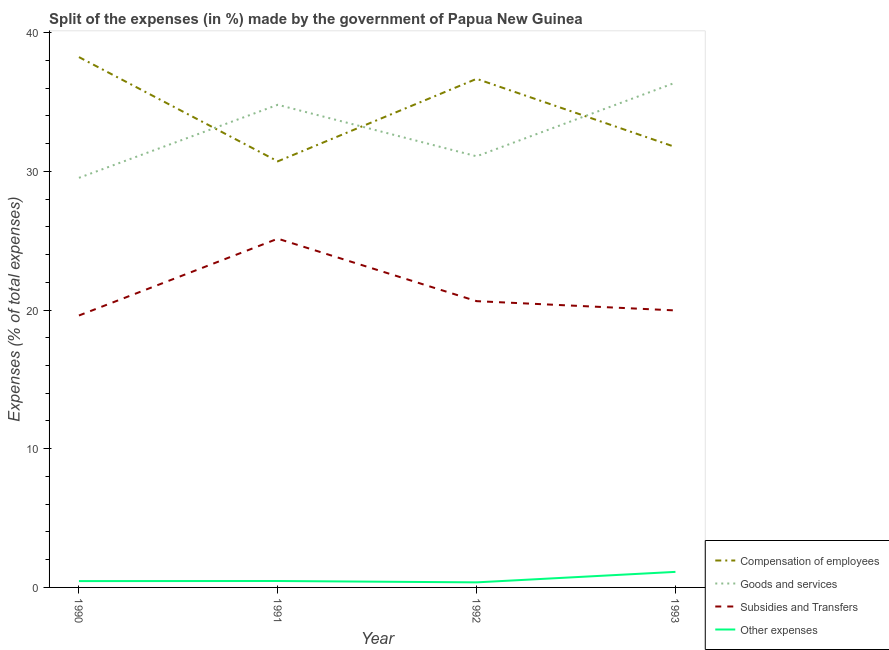How many different coloured lines are there?
Offer a terse response. 4. Is the number of lines equal to the number of legend labels?
Offer a very short reply. Yes. What is the percentage of amount spent on other expenses in 1990?
Ensure brevity in your answer.  0.46. Across all years, what is the maximum percentage of amount spent on goods and services?
Provide a succinct answer. 36.4. Across all years, what is the minimum percentage of amount spent on goods and services?
Offer a very short reply. 29.53. In which year was the percentage of amount spent on subsidies maximum?
Your answer should be compact. 1991. What is the total percentage of amount spent on subsidies in the graph?
Provide a succinct answer. 85.36. What is the difference between the percentage of amount spent on goods and services in 1991 and that in 1993?
Give a very brief answer. -1.6. What is the difference between the percentage of amount spent on subsidies in 1993 and the percentage of amount spent on goods and services in 1992?
Make the answer very short. -11.11. What is the average percentage of amount spent on goods and services per year?
Provide a short and direct response. 32.95. In the year 1992, what is the difference between the percentage of amount spent on compensation of employees and percentage of amount spent on subsidies?
Make the answer very short. 16.03. What is the ratio of the percentage of amount spent on compensation of employees in 1991 to that in 1993?
Provide a succinct answer. 0.97. Is the percentage of amount spent on subsidies in 1990 less than that in 1991?
Keep it short and to the point. Yes. What is the difference between the highest and the second highest percentage of amount spent on subsidies?
Your response must be concise. 4.51. What is the difference between the highest and the lowest percentage of amount spent on goods and services?
Provide a short and direct response. 6.87. Is it the case that in every year, the sum of the percentage of amount spent on compensation of employees and percentage of amount spent on goods and services is greater than the percentage of amount spent on subsidies?
Offer a very short reply. Yes. Does the percentage of amount spent on goods and services monotonically increase over the years?
Give a very brief answer. No. Is the percentage of amount spent on compensation of employees strictly less than the percentage of amount spent on subsidies over the years?
Ensure brevity in your answer.  No. What is the difference between two consecutive major ticks on the Y-axis?
Give a very brief answer. 10. How many legend labels are there?
Provide a succinct answer. 4. How are the legend labels stacked?
Provide a short and direct response. Vertical. What is the title of the graph?
Your answer should be very brief. Split of the expenses (in %) made by the government of Papua New Guinea. Does "Budget management" appear as one of the legend labels in the graph?
Ensure brevity in your answer.  No. What is the label or title of the Y-axis?
Offer a very short reply. Expenses (% of total expenses). What is the Expenses (% of total expenses) of Compensation of employees in 1990?
Provide a short and direct response. 38.24. What is the Expenses (% of total expenses) in Goods and services in 1990?
Your response must be concise. 29.53. What is the Expenses (% of total expenses) in Subsidies and Transfers in 1990?
Give a very brief answer. 19.61. What is the Expenses (% of total expenses) of Other expenses in 1990?
Give a very brief answer. 0.46. What is the Expenses (% of total expenses) in Compensation of employees in 1991?
Your answer should be compact. 30.72. What is the Expenses (% of total expenses) in Goods and services in 1991?
Offer a very short reply. 34.8. What is the Expenses (% of total expenses) of Subsidies and Transfers in 1991?
Offer a terse response. 25.15. What is the Expenses (% of total expenses) of Other expenses in 1991?
Your response must be concise. 0.46. What is the Expenses (% of total expenses) of Compensation of employees in 1992?
Ensure brevity in your answer.  36.67. What is the Expenses (% of total expenses) of Goods and services in 1992?
Your answer should be very brief. 31.08. What is the Expenses (% of total expenses) of Subsidies and Transfers in 1992?
Your response must be concise. 20.64. What is the Expenses (% of total expenses) of Other expenses in 1992?
Offer a terse response. 0.37. What is the Expenses (% of total expenses) of Compensation of employees in 1993?
Offer a terse response. 31.75. What is the Expenses (% of total expenses) in Goods and services in 1993?
Offer a terse response. 36.4. What is the Expenses (% of total expenses) in Subsidies and Transfers in 1993?
Provide a short and direct response. 19.97. What is the Expenses (% of total expenses) of Other expenses in 1993?
Your response must be concise. 1.12. Across all years, what is the maximum Expenses (% of total expenses) of Compensation of employees?
Your response must be concise. 38.24. Across all years, what is the maximum Expenses (% of total expenses) of Goods and services?
Your answer should be compact. 36.4. Across all years, what is the maximum Expenses (% of total expenses) of Subsidies and Transfers?
Give a very brief answer. 25.15. Across all years, what is the maximum Expenses (% of total expenses) in Other expenses?
Your answer should be compact. 1.12. Across all years, what is the minimum Expenses (% of total expenses) in Compensation of employees?
Provide a succinct answer. 30.72. Across all years, what is the minimum Expenses (% of total expenses) of Goods and services?
Offer a terse response. 29.53. Across all years, what is the minimum Expenses (% of total expenses) of Subsidies and Transfers?
Offer a very short reply. 19.61. Across all years, what is the minimum Expenses (% of total expenses) of Other expenses?
Offer a very short reply. 0.37. What is the total Expenses (% of total expenses) of Compensation of employees in the graph?
Your answer should be compact. 137.38. What is the total Expenses (% of total expenses) in Goods and services in the graph?
Make the answer very short. 131.81. What is the total Expenses (% of total expenses) of Subsidies and Transfers in the graph?
Your answer should be compact. 85.36. What is the total Expenses (% of total expenses) of Other expenses in the graph?
Provide a succinct answer. 2.41. What is the difference between the Expenses (% of total expenses) of Compensation of employees in 1990 and that in 1991?
Offer a terse response. 7.52. What is the difference between the Expenses (% of total expenses) in Goods and services in 1990 and that in 1991?
Keep it short and to the point. -5.27. What is the difference between the Expenses (% of total expenses) in Subsidies and Transfers in 1990 and that in 1991?
Give a very brief answer. -5.54. What is the difference between the Expenses (% of total expenses) in Other expenses in 1990 and that in 1991?
Make the answer very short. -0.01. What is the difference between the Expenses (% of total expenses) of Compensation of employees in 1990 and that in 1992?
Your answer should be compact. 1.57. What is the difference between the Expenses (% of total expenses) of Goods and services in 1990 and that in 1992?
Your answer should be compact. -1.55. What is the difference between the Expenses (% of total expenses) in Subsidies and Transfers in 1990 and that in 1992?
Offer a terse response. -1.03. What is the difference between the Expenses (% of total expenses) in Other expenses in 1990 and that in 1992?
Ensure brevity in your answer.  0.09. What is the difference between the Expenses (% of total expenses) in Compensation of employees in 1990 and that in 1993?
Provide a succinct answer. 6.49. What is the difference between the Expenses (% of total expenses) in Goods and services in 1990 and that in 1993?
Your answer should be compact. -6.87. What is the difference between the Expenses (% of total expenses) of Subsidies and Transfers in 1990 and that in 1993?
Ensure brevity in your answer.  -0.37. What is the difference between the Expenses (% of total expenses) in Other expenses in 1990 and that in 1993?
Your response must be concise. -0.67. What is the difference between the Expenses (% of total expenses) in Compensation of employees in 1991 and that in 1992?
Offer a very short reply. -5.95. What is the difference between the Expenses (% of total expenses) of Goods and services in 1991 and that in 1992?
Provide a short and direct response. 3.71. What is the difference between the Expenses (% of total expenses) in Subsidies and Transfers in 1991 and that in 1992?
Your answer should be compact. 4.51. What is the difference between the Expenses (% of total expenses) of Other expenses in 1991 and that in 1992?
Your answer should be very brief. 0.1. What is the difference between the Expenses (% of total expenses) in Compensation of employees in 1991 and that in 1993?
Provide a short and direct response. -1.03. What is the difference between the Expenses (% of total expenses) in Goods and services in 1991 and that in 1993?
Your answer should be very brief. -1.6. What is the difference between the Expenses (% of total expenses) in Subsidies and Transfers in 1991 and that in 1993?
Provide a short and direct response. 5.17. What is the difference between the Expenses (% of total expenses) of Other expenses in 1991 and that in 1993?
Offer a terse response. -0.66. What is the difference between the Expenses (% of total expenses) of Compensation of employees in 1992 and that in 1993?
Provide a short and direct response. 4.92. What is the difference between the Expenses (% of total expenses) of Goods and services in 1992 and that in 1993?
Your answer should be compact. -5.31. What is the difference between the Expenses (% of total expenses) of Subsidies and Transfers in 1992 and that in 1993?
Your response must be concise. 0.67. What is the difference between the Expenses (% of total expenses) of Other expenses in 1992 and that in 1993?
Your response must be concise. -0.76. What is the difference between the Expenses (% of total expenses) in Compensation of employees in 1990 and the Expenses (% of total expenses) in Goods and services in 1991?
Your answer should be compact. 3.44. What is the difference between the Expenses (% of total expenses) of Compensation of employees in 1990 and the Expenses (% of total expenses) of Subsidies and Transfers in 1991?
Keep it short and to the point. 13.09. What is the difference between the Expenses (% of total expenses) of Compensation of employees in 1990 and the Expenses (% of total expenses) of Other expenses in 1991?
Your answer should be compact. 37.77. What is the difference between the Expenses (% of total expenses) in Goods and services in 1990 and the Expenses (% of total expenses) in Subsidies and Transfers in 1991?
Ensure brevity in your answer.  4.39. What is the difference between the Expenses (% of total expenses) in Goods and services in 1990 and the Expenses (% of total expenses) in Other expenses in 1991?
Give a very brief answer. 29.07. What is the difference between the Expenses (% of total expenses) in Subsidies and Transfers in 1990 and the Expenses (% of total expenses) in Other expenses in 1991?
Provide a succinct answer. 19.14. What is the difference between the Expenses (% of total expenses) in Compensation of employees in 1990 and the Expenses (% of total expenses) in Goods and services in 1992?
Your answer should be very brief. 7.15. What is the difference between the Expenses (% of total expenses) in Compensation of employees in 1990 and the Expenses (% of total expenses) in Subsidies and Transfers in 1992?
Offer a terse response. 17.6. What is the difference between the Expenses (% of total expenses) of Compensation of employees in 1990 and the Expenses (% of total expenses) of Other expenses in 1992?
Your answer should be very brief. 37.87. What is the difference between the Expenses (% of total expenses) of Goods and services in 1990 and the Expenses (% of total expenses) of Subsidies and Transfers in 1992?
Keep it short and to the point. 8.89. What is the difference between the Expenses (% of total expenses) in Goods and services in 1990 and the Expenses (% of total expenses) in Other expenses in 1992?
Your response must be concise. 29.17. What is the difference between the Expenses (% of total expenses) of Subsidies and Transfers in 1990 and the Expenses (% of total expenses) of Other expenses in 1992?
Your answer should be compact. 19.24. What is the difference between the Expenses (% of total expenses) of Compensation of employees in 1990 and the Expenses (% of total expenses) of Goods and services in 1993?
Make the answer very short. 1.84. What is the difference between the Expenses (% of total expenses) in Compensation of employees in 1990 and the Expenses (% of total expenses) in Subsidies and Transfers in 1993?
Give a very brief answer. 18.27. What is the difference between the Expenses (% of total expenses) in Compensation of employees in 1990 and the Expenses (% of total expenses) in Other expenses in 1993?
Make the answer very short. 37.12. What is the difference between the Expenses (% of total expenses) in Goods and services in 1990 and the Expenses (% of total expenses) in Subsidies and Transfers in 1993?
Keep it short and to the point. 9.56. What is the difference between the Expenses (% of total expenses) of Goods and services in 1990 and the Expenses (% of total expenses) of Other expenses in 1993?
Provide a succinct answer. 28.41. What is the difference between the Expenses (% of total expenses) in Subsidies and Transfers in 1990 and the Expenses (% of total expenses) in Other expenses in 1993?
Offer a very short reply. 18.48. What is the difference between the Expenses (% of total expenses) in Compensation of employees in 1991 and the Expenses (% of total expenses) in Goods and services in 1992?
Offer a very short reply. -0.36. What is the difference between the Expenses (% of total expenses) in Compensation of employees in 1991 and the Expenses (% of total expenses) in Subsidies and Transfers in 1992?
Provide a succinct answer. 10.08. What is the difference between the Expenses (% of total expenses) of Compensation of employees in 1991 and the Expenses (% of total expenses) of Other expenses in 1992?
Keep it short and to the point. 30.36. What is the difference between the Expenses (% of total expenses) in Goods and services in 1991 and the Expenses (% of total expenses) in Subsidies and Transfers in 1992?
Provide a short and direct response. 14.16. What is the difference between the Expenses (% of total expenses) in Goods and services in 1991 and the Expenses (% of total expenses) in Other expenses in 1992?
Ensure brevity in your answer.  34.43. What is the difference between the Expenses (% of total expenses) of Subsidies and Transfers in 1991 and the Expenses (% of total expenses) of Other expenses in 1992?
Provide a succinct answer. 24.78. What is the difference between the Expenses (% of total expenses) of Compensation of employees in 1991 and the Expenses (% of total expenses) of Goods and services in 1993?
Your answer should be very brief. -5.68. What is the difference between the Expenses (% of total expenses) in Compensation of employees in 1991 and the Expenses (% of total expenses) in Subsidies and Transfers in 1993?
Your answer should be very brief. 10.75. What is the difference between the Expenses (% of total expenses) of Compensation of employees in 1991 and the Expenses (% of total expenses) of Other expenses in 1993?
Make the answer very short. 29.6. What is the difference between the Expenses (% of total expenses) of Goods and services in 1991 and the Expenses (% of total expenses) of Subsidies and Transfers in 1993?
Offer a terse response. 14.83. What is the difference between the Expenses (% of total expenses) of Goods and services in 1991 and the Expenses (% of total expenses) of Other expenses in 1993?
Your answer should be very brief. 33.68. What is the difference between the Expenses (% of total expenses) in Subsidies and Transfers in 1991 and the Expenses (% of total expenses) in Other expenses in 1993?
Your answer should be compact. 24.02. What is the difference between the Expenses (% of total expenses) in Compensation of employees in 1992 and the Expenses (% of total expenses) in Goods and services in 1993?
Give a very brief answer. 0.27. What is the difference between the Expenses (% of total expenses) in Compensation of employees in 1992 and the Expenses (% of total expenses) in Subsidies and Transfers in 1993?
Offer a very short reply. 16.7. What is the difference between the Expenses (% of total expenses) in Compensation of employees in 1992 and the Expenses (% of total expenses) in Other expenses in 1993?
Provide a succinct answer. 35.55. What is the difference between the Expenses (% of total expenses) of Goods and services in 1992 and the Expenses (% of total expenses) of Subsidies and Transfers in 1993?
Offer a terse response. 11.11. What is the difference between the Expenses (% of total expenses) in Goods and services in 1992 and the Expenses (% of total expenses) in Other expenses in 1993?
Your answer should be compact. 29.96. What is the difference between the Expenses (% of total expenses) in Subsidies and Transfers in 1992 and the Expenses (% of total expenses) in Other expenses in 1993?
Provide a succinct answer. 19.52. What is the average Expenses (% of total expenses) of Compensation of employees per year?
Your answer should be very brief. 34.34. What is the average Expenses (% of total expenses) in Goods and services per year?
Your answer should be very brief. 32.95. What is the average Expenses (% of total expenses) in Subsidies and Transfers per year?
Your answer should be compact. 21.34. What is the average Expenses (% of total expenses) in Other expenses per year?
Your answer should be very brief. 0.6. In the year 1990, what is the difference between the Expenses (% of total expenses) of Compensation of employees and Expenses (% of total expenses) of Goods and services?
Make the answer very short. 8.71. In the year 1990, what is the difference between the Expenses (% of total expenses) of Compensation of employees and Expenses (% of total expenses) of Subsidies and Transfers?
Offer a terse response. 18.63. In the year 1990, what is the difference between the Expenses (% of total expenses) of Compensation of employees and Expenses (% of total expenses) of Other expenses?
Ensure brevity in your answer.  37.78. In the year 1990, what is the difference between the Expenses (% of total expenses) of Goods and services and Expenses (% of total expenses) of Subsidies and Transfers?
Offer a very short reply. 9.93. In the year 1990, what is the difference between the Expenses (% of total expenses) in Goods and services and Expenses (% of total expenses) in Other expenses?
Provide a succinct answer. 29.08. In the year 1990, what is the difference between the Expenses (% of total expenses) of Subsidies and Transfers and Expenses (% of total expenses) of Other expenses?
Offer a very short reply. 19.15. In the year 1991, what is the difference between the Expenses (% of total expenses) of Compensation of employees and Expenses (% of total expenses) of Goods and services?
Ensure brevity in your answer.  -4.08. In the year 1991, what is the difference between the Expenses (% of total expenses) in Compensation of employees and Expenses (% of total expenses) in Subsidies and Transfers?
Provide a succinct answer. 5.58. In the year 1991, what is the difference between the Expenses (% of total expenses) of Compensation of employees and Expenses (% of total expenses) of Other expenses?
Give a very brief answer. 30.26. In the year 1991, what is the difference between the Expenses (% of total expenses) of Goods and services and Expenses (% of total expenses) of Subsidies and Transfers?
Make the answer very short. 9.65. In the year 1991, what is the difference between the Expenses (% of total expenses) of Goods and services and Expenses (% of total expenses) of Other expenses?
Your response must be concise. 34.34. In the year 1991, what is the difference between the Expenses (% of total expenses) of Subsidies and Transfers and Expenses (% of total expenses) of Other expenses?
Provide a succinct answer. 24.68. In the year 1992, what is the difference between the Expenses (% of total expenses) in Compensation of employees and Expenses (% of total expenses) in Goods and services?
Offer a terse response. 5.59. In the year 1992, what is the difference between the Expenses (% of total expenses) of Compensation of employees and Expenses (% of total expenses) of Subsidies and Transfers?
Your answer should be compact. 16.03. In the year 1992, what is the difference between the Expenses (% of total expenses) of Compensation of employees and Expenses (% of total expenses) of Other expenses?
Ensure brevity in your answer.  36.31. In the year 1992, what is the difference between the Expenses (% of total expenses) of Goods and services and Expenses (% of total expenses) of Subsidies and Transfers?
Offer a terse response. 10.44. In the year 1992, what is the difference between the Expenses (% of total expenses) in Goods and services and Expenses (% of total expenses) in Other expenses?
Keep it short and to the point. 30.72. In the year 1992, what is the difference between the Expenses (% of total expenses) of Subsidies and Transfers and Expenses (% of total expenses) of Other expenses?
Provide a short and direct response. 20.28. In the year 1993, what is the difference between the Expenses (% of total expenses) of Compensation of employees and Expenses (% of total expenses) of Goods and services?
Ensure brevity in your answer.  -4.65. In the year 1993, what is the difference between the Expenses (% of total expenses) in Compensation of employees and Expenses (% of total expenses) in Subsidies and Transfers?
Provide a short and direct response. 11.78. In the year 1993, what is the difference between the Expenses (% of total expenses) of Compensation of employees and Expenses (% of total expenses) of Other expenses?
Keep it short and to the point. 30.63. In the year 1993, what is the difference between the Expenses (% of total expenses) of Goods and services and Expenses (% of total expenses) of Subsidies and Transfers?
Your answer should be very brief. 16.43. In the year 1993, what is the difference between the Expenses (% of total expenses) in Goods and services and Expenses (% of total expenses) in Other expenses?
Your answer should be compact. 35.28. In the year 1993, what is the difference between the Expenses (% of total expenses) of Subsidies and Transfers and Expenses (% of total expenses) of Other expenses?
Make the answer very short. 18.85. What is the ratio of the Expenses (% of total expenses) in Compensation of employees in 1990 to that in 1991?
Give a very brief answer. 1.24. What is the ratio of the Expenses (% of total expenses) in Goods and services in 1990 to that in 1991?
Provide a succinct answer. 0.85. What is the ratio of the Expenses (% of total expenses) in Subsidies and Transfers in 1990 to that in 1991?
Give a very brief answer. 0.78. What is the ratio of the Expenses (% of total expenses) of Other expenses in 1990 to that in 1991?
Give a very brief answer. 0.98. What is the ratio of the Expenses (% of total expenses) of Compensation of employees in 1990 to that in 1992?
Your answer should be compact. 1.04. What is the ratio of the Expenses (% of total expenses) of Subsidies and Transfers in 1990 to that in 1992?
Provide a succinct answer. 0.95. What is the ratio of the Expenses (% of total expenses) in Other expenses in 1990 to that in 1992?
Make the answer very short. 1.25. What is the ratio of the Expenses (% of total expenses) in Compensation of employees in 1990 to that in 1993?
Give a very brief answer. 1.2. What is the ratio of the Expenses (% of total expenses) in Goods and services in 1990 to that in 1993?
Provide a succinct answer. 0.81. What is the ratio of the Expenses (% of total expenses) in Subsidies and Transfers in 1990 to that in 1993?
Make the answer very short. 0.98. What is the ratio of the Expenses (% of total expenses) of Other expenses in 1990 to that in 1993?
Keep it short and to the point. 0.41. What is the ratio of the Expenses (% of total expenses) of Compensation of employees in 1991 to that in 1992?
Provide a short and direct response. 0.84. What is the ratio of the Expenses (% of total expenses) of Goods and services in 1991 to that in 1992?
Offer a very short reply. 1.12. What is the ratio of the Expenses (% of total expenses) in Subsidies and Transfers in 1991 to that in 1992?
Make the answer very short. 1.22. What is the ratio of the Expenses (% of total expenses) of Other expenses in 1991 to that in 1992?
Your answer should be compact. 1.27. What is the ratio of the Expenses (% of total expenses) of Compensation of employees in 1991 to that in 1993?
Make the answer very short. 0.97. What is the ratio of the Expenses (% of total expenses) of Goods and services in 1991 to that in 1993?
Your answer should be compact. 0.96. What is the ratio of the Expenses (% of total expenses) in Subsidies and Transfers in 1991 to that in 1993?
Your answer should be very brief. 1.26. What is the ratio of the Expenses (% of total expenses) of Other expenses in 1991 to that in 1993?
Your answer should be very brief. 0.41. What is the ratio of the Expenses (% of total expenses) of Compensation of employees in 1992 to that in 1993?
Provide a succinct answer. 1.16. What is the ratio of the Expenses (% of total expenses) of Goods and services in 1992 to that in 1993?
Offer a very short reply. 0.85. What is the ratio of the Expenses (% of total expenses) of Subsidies and Transfers in 1992 to that in 1993?
Provide a short and direct response. 1.03. What is the ratio of the Expenses (% of total expenses) of Other expenses in 1992 to that in 1993?
Give a very brief answer. 0.33. What is the difference between the highest and the second highest Expenses (% of total expenses) in Compensation of employees?
Your answer should be compact. 1.57. What is the difference between the highest and the second highest Expenses (% of total expenses) of Goods and services?
Make the answer very short. 1.6. What is the difference between the highest and the second highest Expenses (% of total expenses) of Subsidies and Transfers?
Your answer should be compact. 4.51. What is the difference between the highest and the second highest Expenses (% of total expenses) of Other expenses?
Offer a very short reply. 0.66. What is the difference between the highest and the lowest Expenses (% of total expenses) of Compensation of employees?
Ensure brevity in your answer.  7.52. What is the difference between the highest and the lowest Expenses (% of total expenses) in Goods and services?
Provide a short and direct response. 6.87. What is the difference between the highest and the lowest Expenses (% of total expenses) of Subsidies and Transfers?
Provide a short and direct response. 5.54. What is the difference between the highest and the lowest Expenses (% of total expenses) of Other expenses?
Your answer should be very brief. 0.76. 